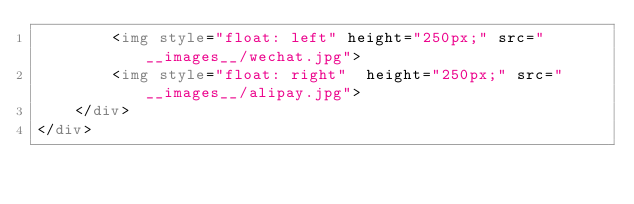<code> <loc_0><loc_0><loc_500><loc_500><_HTML_>        <img style="float: left" height="250px;" src="__images__/wechat.jpg">
        <img style="float: right"  height="250px;" src="__images__/alipay.jpg">
    </div>
</div>
</code> 